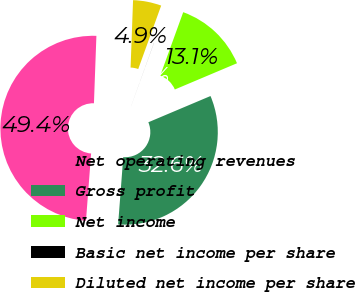Convert chart. <chart><loc_0><loc_0><loc_500><loc_500><pie_chart><fcel>Net operating revenues<fcel>Gross profit<fcel>Net income<fcel>Basic net income per share<fcel>Diluted net income per share<nl><fcel>49.37%<fcel>32.57%<fcel>13.11%<fcel>0.01%<fcel>4.94%<nl></chart> 